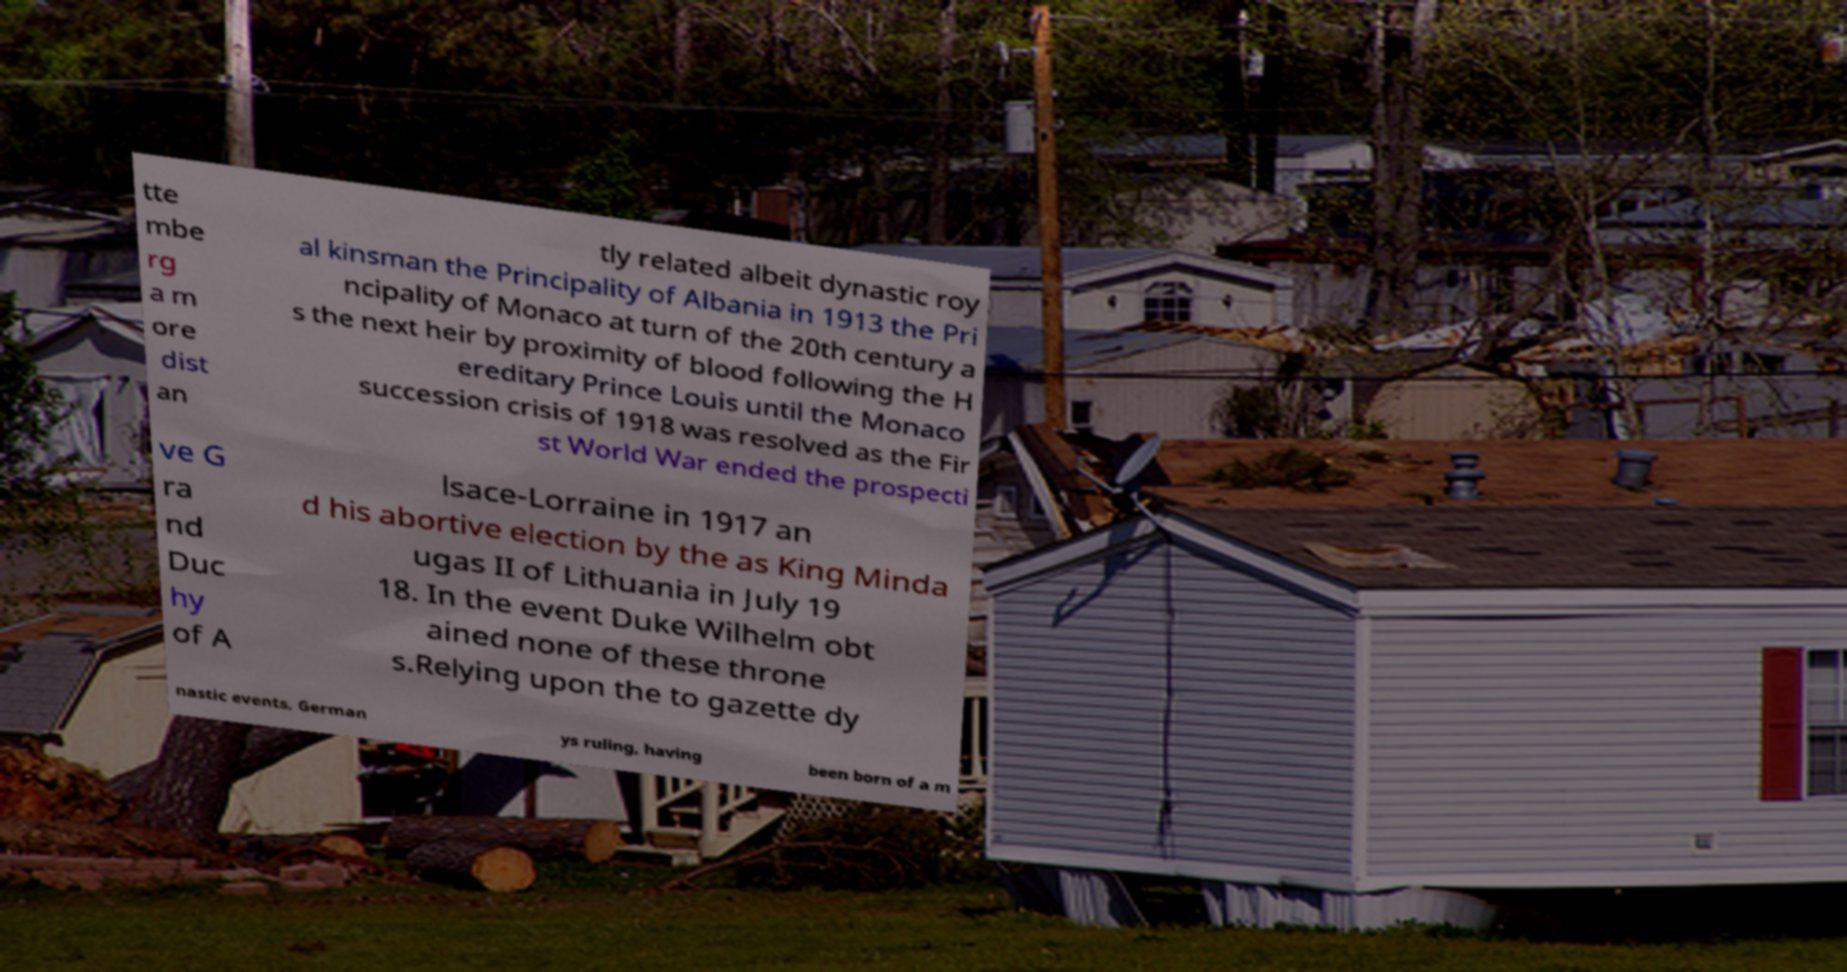Can you accurately transcribe the text from the provided image for me? tte mbe rg a m ore dist an tly related albeit dynastic roy al kinsman the Principality of Albania in 1913 the Pri ncipality of Monaco at turn of the 20th century a s the next heir by proximity of blood following the H ereditary Prince Louis until the Monaco succession crisis of 1918 was resolved as the Fir st World War ended the prospecti ve G ra nd Duc hy of A lsace-Lorraine in 1917 an d his abortive election by the as King Minda ugas II of Lithuania in July 19 18. In the event Duke Wilhelm obt ained none of these throne s.Relying upon the to gazette dy nastic events, German ys ruling, having been born of a m 